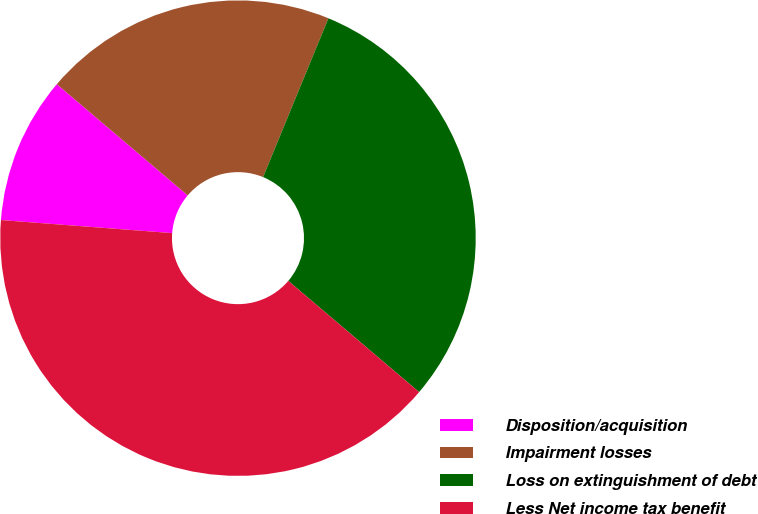Convert chart to OTSL. <chart><loc_0><loc_0><loc_500><loc_500><pie_chart><fcel>Disposition/acquisition<fcel>Impairment losses<fcel>Loss on extinguishment of debt<fcel>Less Net income tax benefit<nl><fcel>10.0%<fcel>20.0%<fcel>30.0%<fcel>40.0%<nl></chart> 